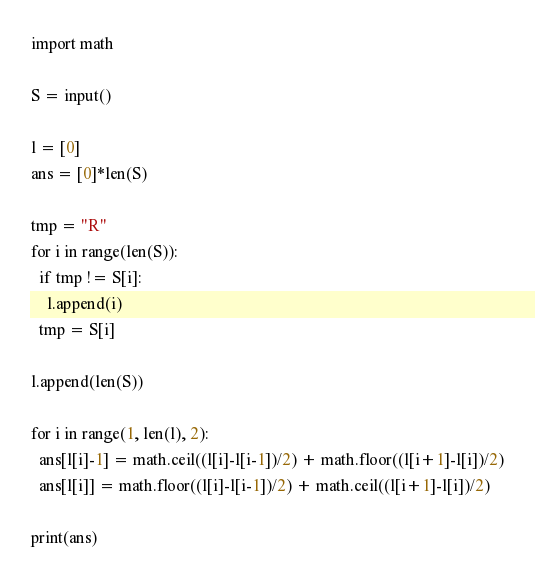<code> <loc_0><loc_0><loc_500><loc_500><_Python_>import math

S = input()

l = [0]
ans = [0]*len(S)

tmp = "R"
for i in range(len(S)):
  if tmp != S[i]:
    l.append(i)
  tmp = S[i]

l.append(len(S))

for i in range(1, len(l), 2):
  ans[l[i]-1] = math.ceil((l[i]-l[i-1])/2) + math.floor((l[i+1]-l[i])/2)
  ans[l[i]] = math.floor((l[i]-l[i-1])/2) + math.ceil((l[i+1]-l[i])/2)

print(ans)</code> 